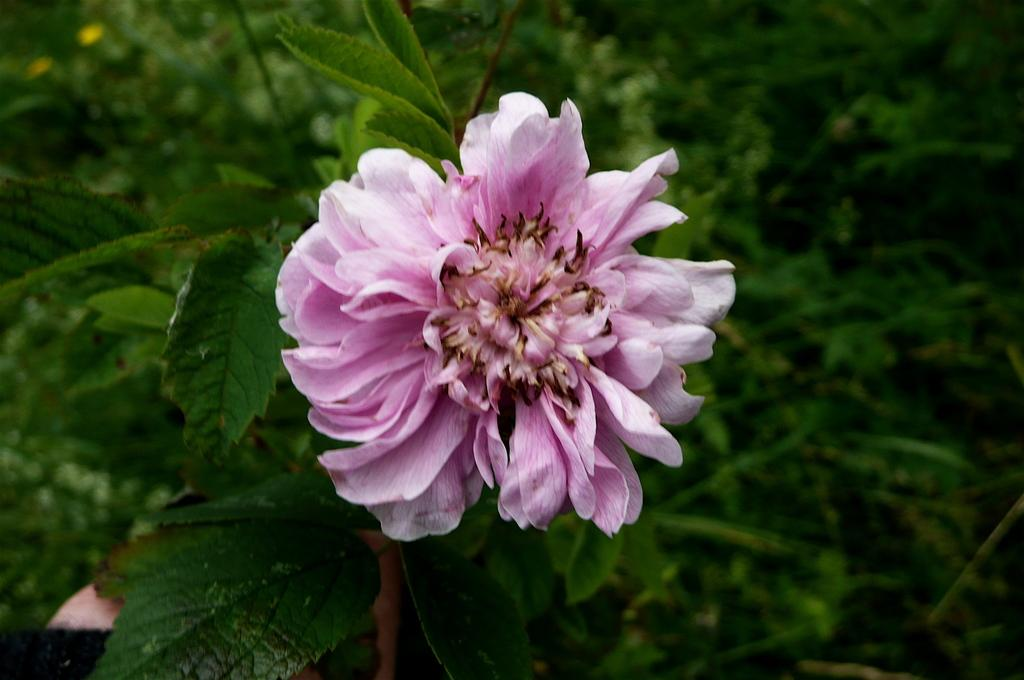What is the main subject of the image? There is a beautiful flower in the image. What else can be seen in the image besides the flower? There are leaves of the plant in the image. How much money is being exchanged between the police officers in the image? There are no police officers or money present in the image; it features a beautiful flower and its leaves. 